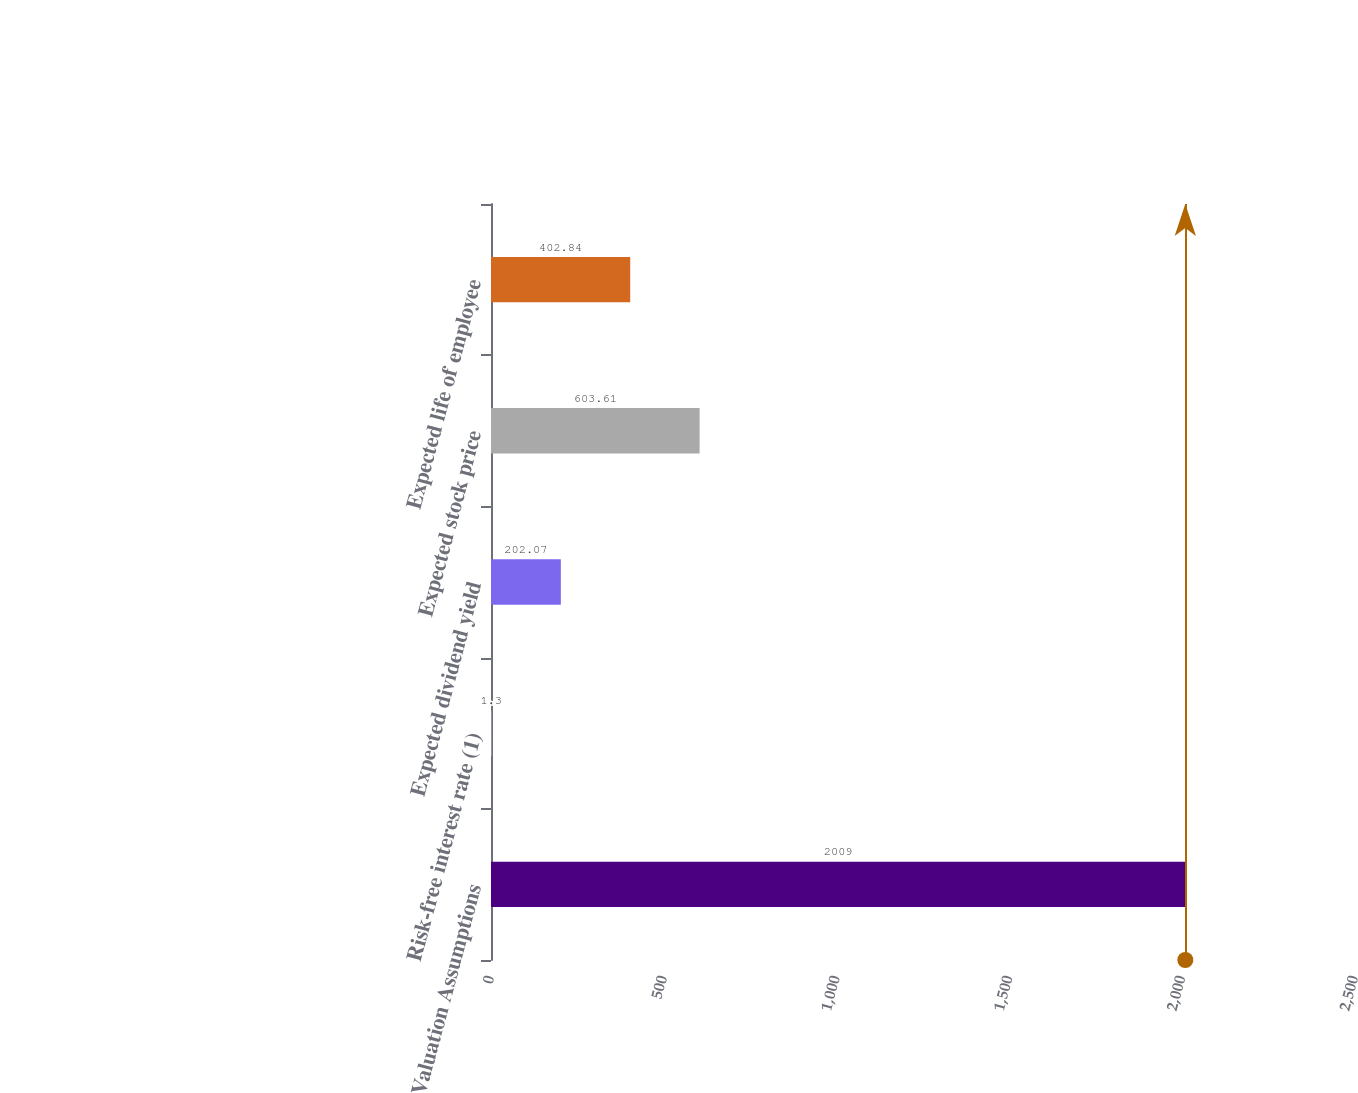Convert chart to OTSL. <chart><loc_0><loc_0><loc_500><loc_500><bar_chart><fcel>Valuation Assumptions<fcel>Risk-free interest rate (1)<fcel>Expected dividend yield<fcel>Expected stock price<fcel>Expected life of employee<nl><fcel>2009<fcel>1.3<fcel>202.07<fcel>603.61<fcel>402.84<nl></chart> 